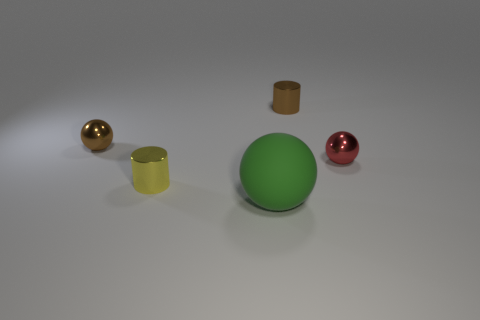Add 5 tiny yellow things. How many objects exist? 10 Subtract all cylinders. How many objects are left? 3 Add 4 tiny red metallic objects. How many tiny red metallic objects exist? 5 Subtract 0 red cylinders. How many objects are left? 5 Subtract all big blue rubber blocks. Subtract all small yellow shiny objects. How many objects are left? 4 Add 2 brown shiny cylinders. How many brown shiny cylinders are left? 3 